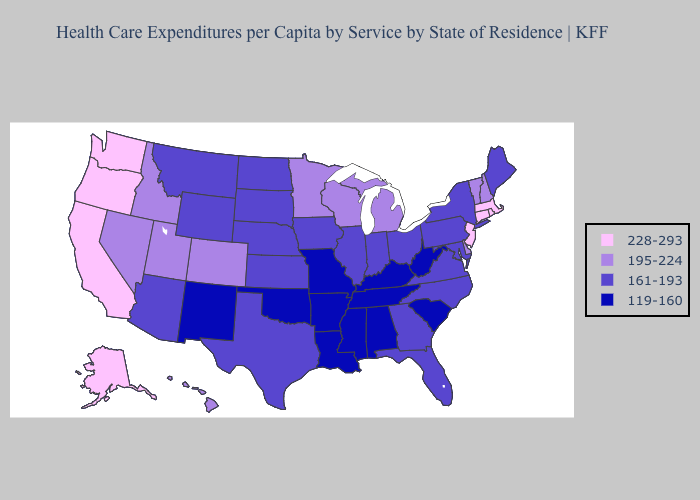Among the states that border Utah , which have the highest value?
Quick response, please. Colorado, Idaho, Nevada. Name the states that have a value in the range 228-293?
Short answer required. Alaska, California, Connecticut, Massachusetts, New Jersey, Oregon, Rhode Island, Washington. Among the states that border Virginia , does Maryland have the lowest value?
Short answer required. No. What is the highest value in the West ?
Write a very short answer. 228-293. Name the states that have a value in the range 195-224?
Concise answer only. Colorado, Delaware, Hawaii, Idaho, Michigan, Minnesota, Nevada, New Hampshire, Utah, Vermont, Wisconsin. Does Colorado have the highest value in the West?
Concise answer only. No. What is the value of Indiana?
Answer briefly. 161-193. What is the value of Vermont?
Answer briefly. 195-224. Which states hav the highest value in the South?
Give a very brief answer. Delaware. Name the states that have a value in the range 195-224?
Write a very short answer. Colorado, Delaware, Hawaii, Idaho, Michigan, Minnesota, Nevada, New Hampshire, Utah, Vermont, Wisconsin. Does the first symbol in the legend represent the smallest category?
Concise answer only. No. What is the highest value in the Northeast ?
Answer briefly. 228-293. Among the states that border Idaho , which have the highest value?
Keep it brief. Oregon, Washington. What is the value of Wisconsin?
Quick response, please. 195-224. 